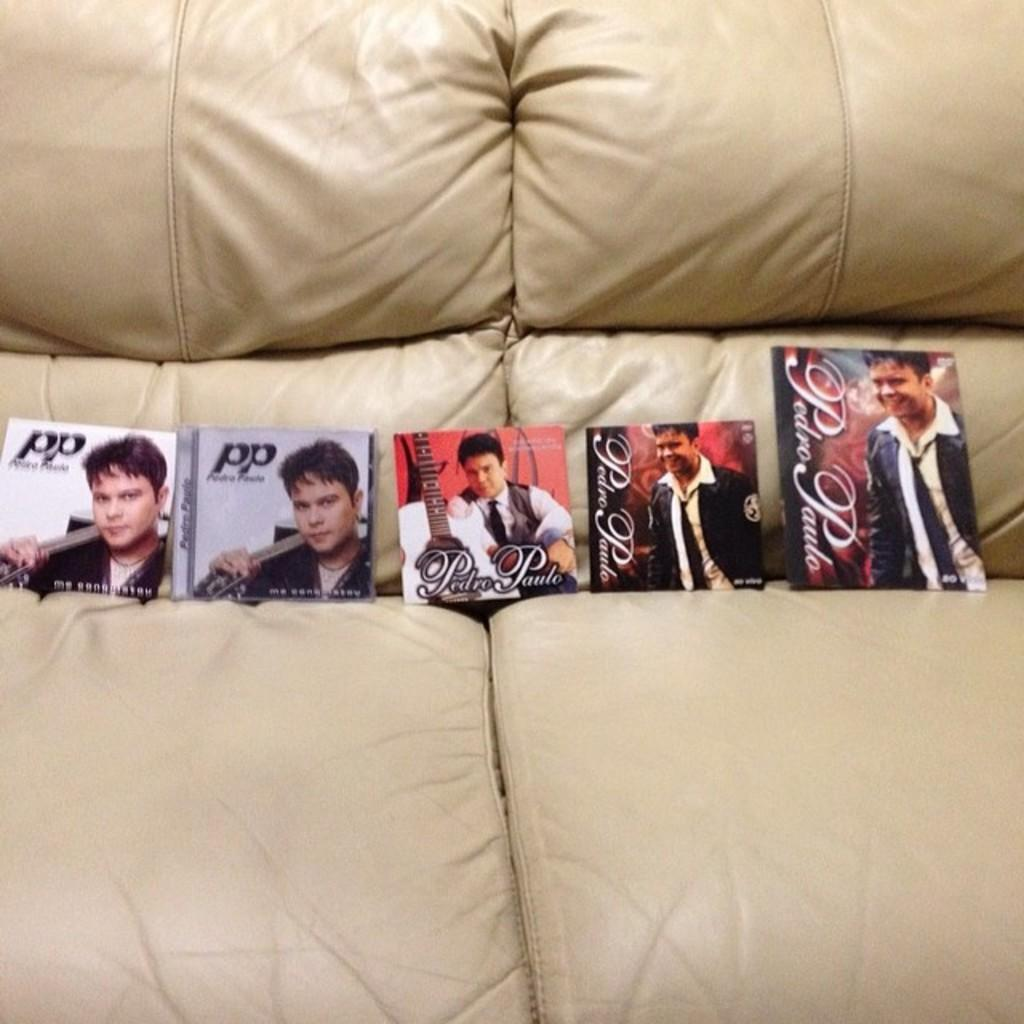What can be seen in the image? There are photos in the image. Where are the photos located? The photos are on a cream-colored couch. What type of noise can be heard coming from the sidewalk in the image? There is no sidewalk or noise present in the image; it only features photos on a cream-colored couch. 